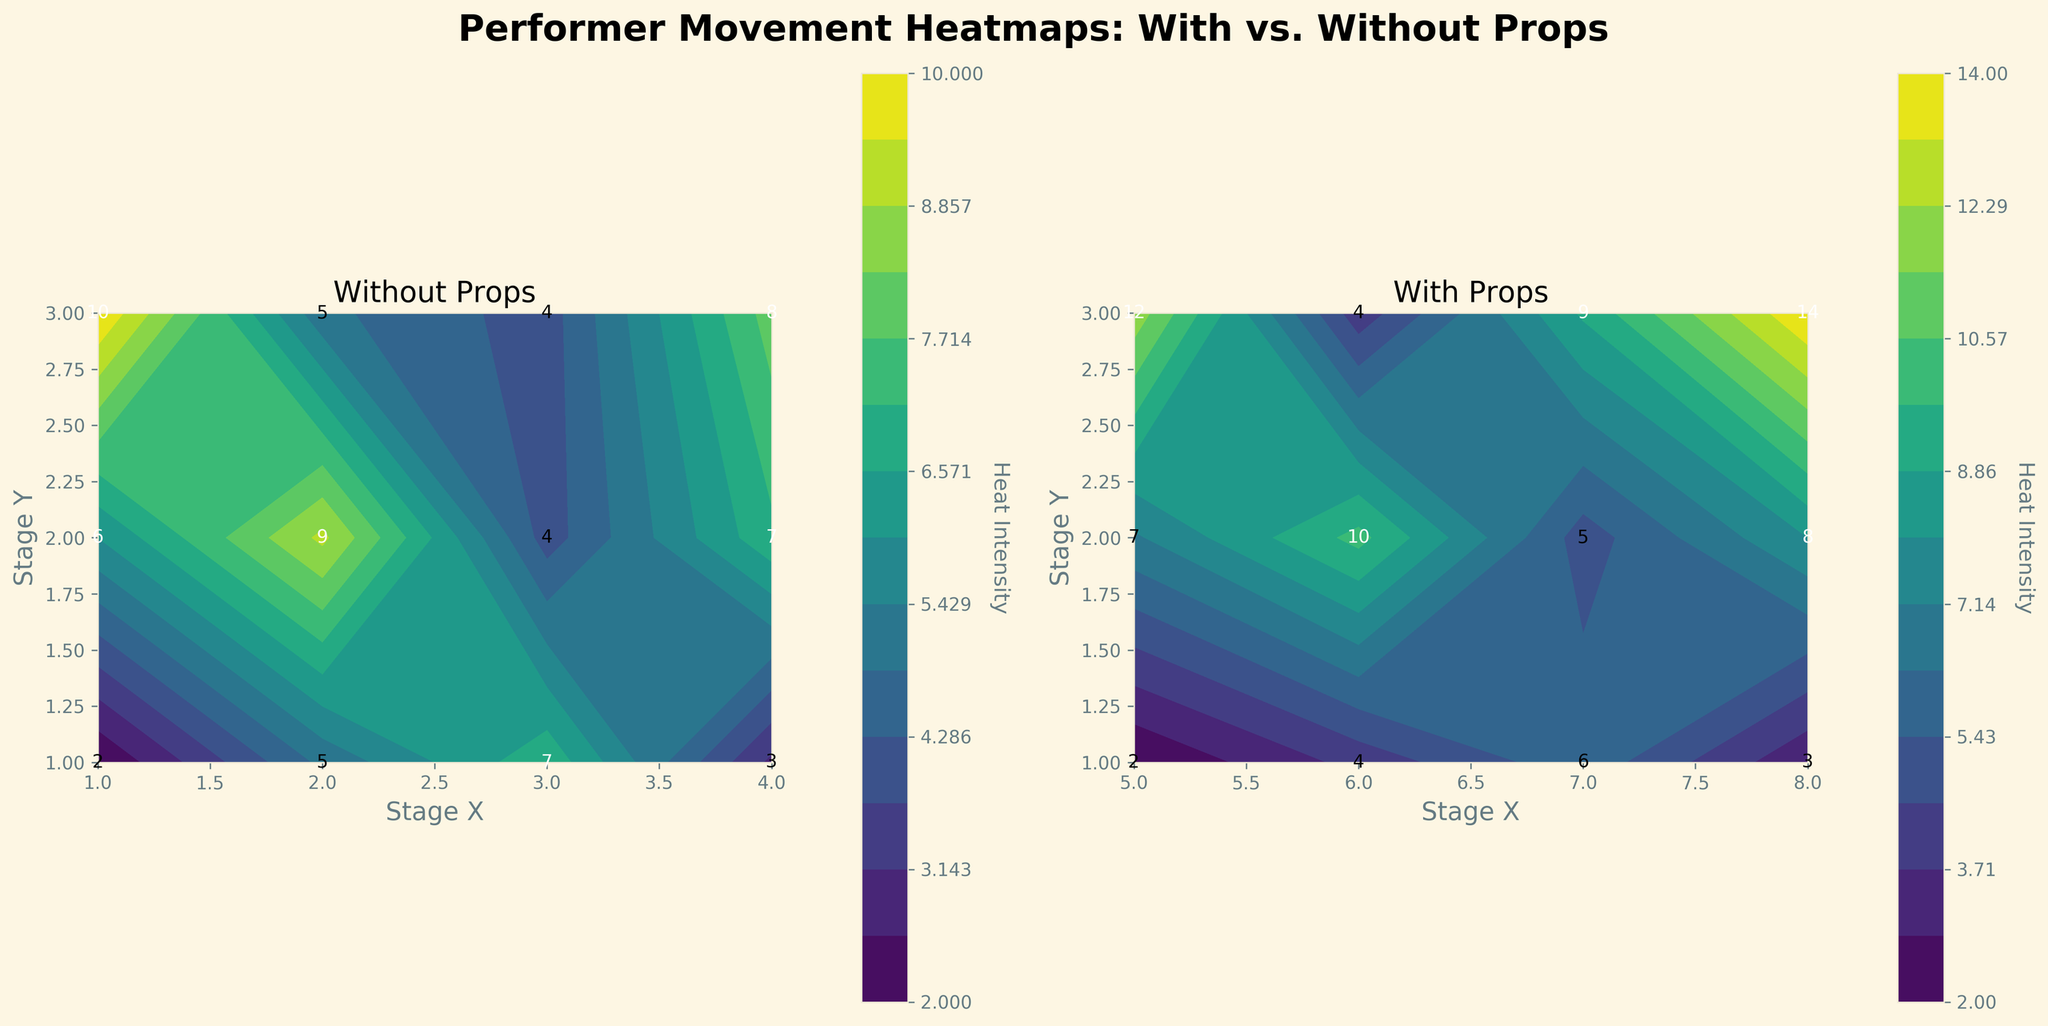what is the title of the figure? The title of the figure is given at the top center of the plot. It reads "Performer Movement Heatmaps: With vs. Without Props".
Answer: Performer Movement Heatmaps: With vs. Without Props What's the heat intensity at Stage (3,3) without props? Look for the value labeled at the (3, 3) position in the "Without Props" subplot. It is represented as "10".
Answer: 10 Which subplot shows higher heat intensity values? Compare the color intensity and the labeled heat values in both the "With Props" and "Without Props" subplots. The subplot "With Props" has higher values with heat intensity going up to 14.
Answer: With Props What is the minimum heat intensity level across both subplots? Identify the lowest labeled heat intensity in both subplots. The lowest value is 2, found in both "With Props" and "Without Props".
Answer: 2 How does the heat intensity change along Stage Y-axis from bottom to top in the "With Props" subplot at Stage X=6? Examine the labeled heat intensity values as Stage Y increases from 1 to 3 at Stage X=6 in the "With Props" subplot. The values increase from 3, to 7, and then to 10.
Answer: Increases Does the central area (Stage X: 2-3, Stage Y: 2-3) have higher heat intensity without props or with props? Calculate the average heat intensity for the central area by summing individual intensities and dividing by the number of points for both subplots. Without props: (6 + 9 + 7 + 10)/4 = 8; With props: (7 + 10 + 8 + 12)/4 = 9.25
Answer: With Props At Stage X=4, what is the difference in heat intensity between Stage Y=1 and Stage Y=3 without props? Subtract the heat intensity at Stage Y=1 from the value at Stage Y=3 in the "Without Props" subplot. Difference: 8 - 5 = 3
Answer: 3 What's the average heat intensity at Stage X=7 with props? Calculate the mean of the heat intensities along the Y-axis (1 to 3) at Stage X=7 in the "With Props" subplot: (5 + 8 + 12)/3 = 25/3 ≈ 8.33
Answer: 8.33 Are there any positions in the "With Props" subplot where the heat intensity exceeds 12? Check all labeled heat intensities in the "With Props" subplot and see if any value exceeds 12. There is one position at (8, 3) with a value of 14.
Answer: Yes 